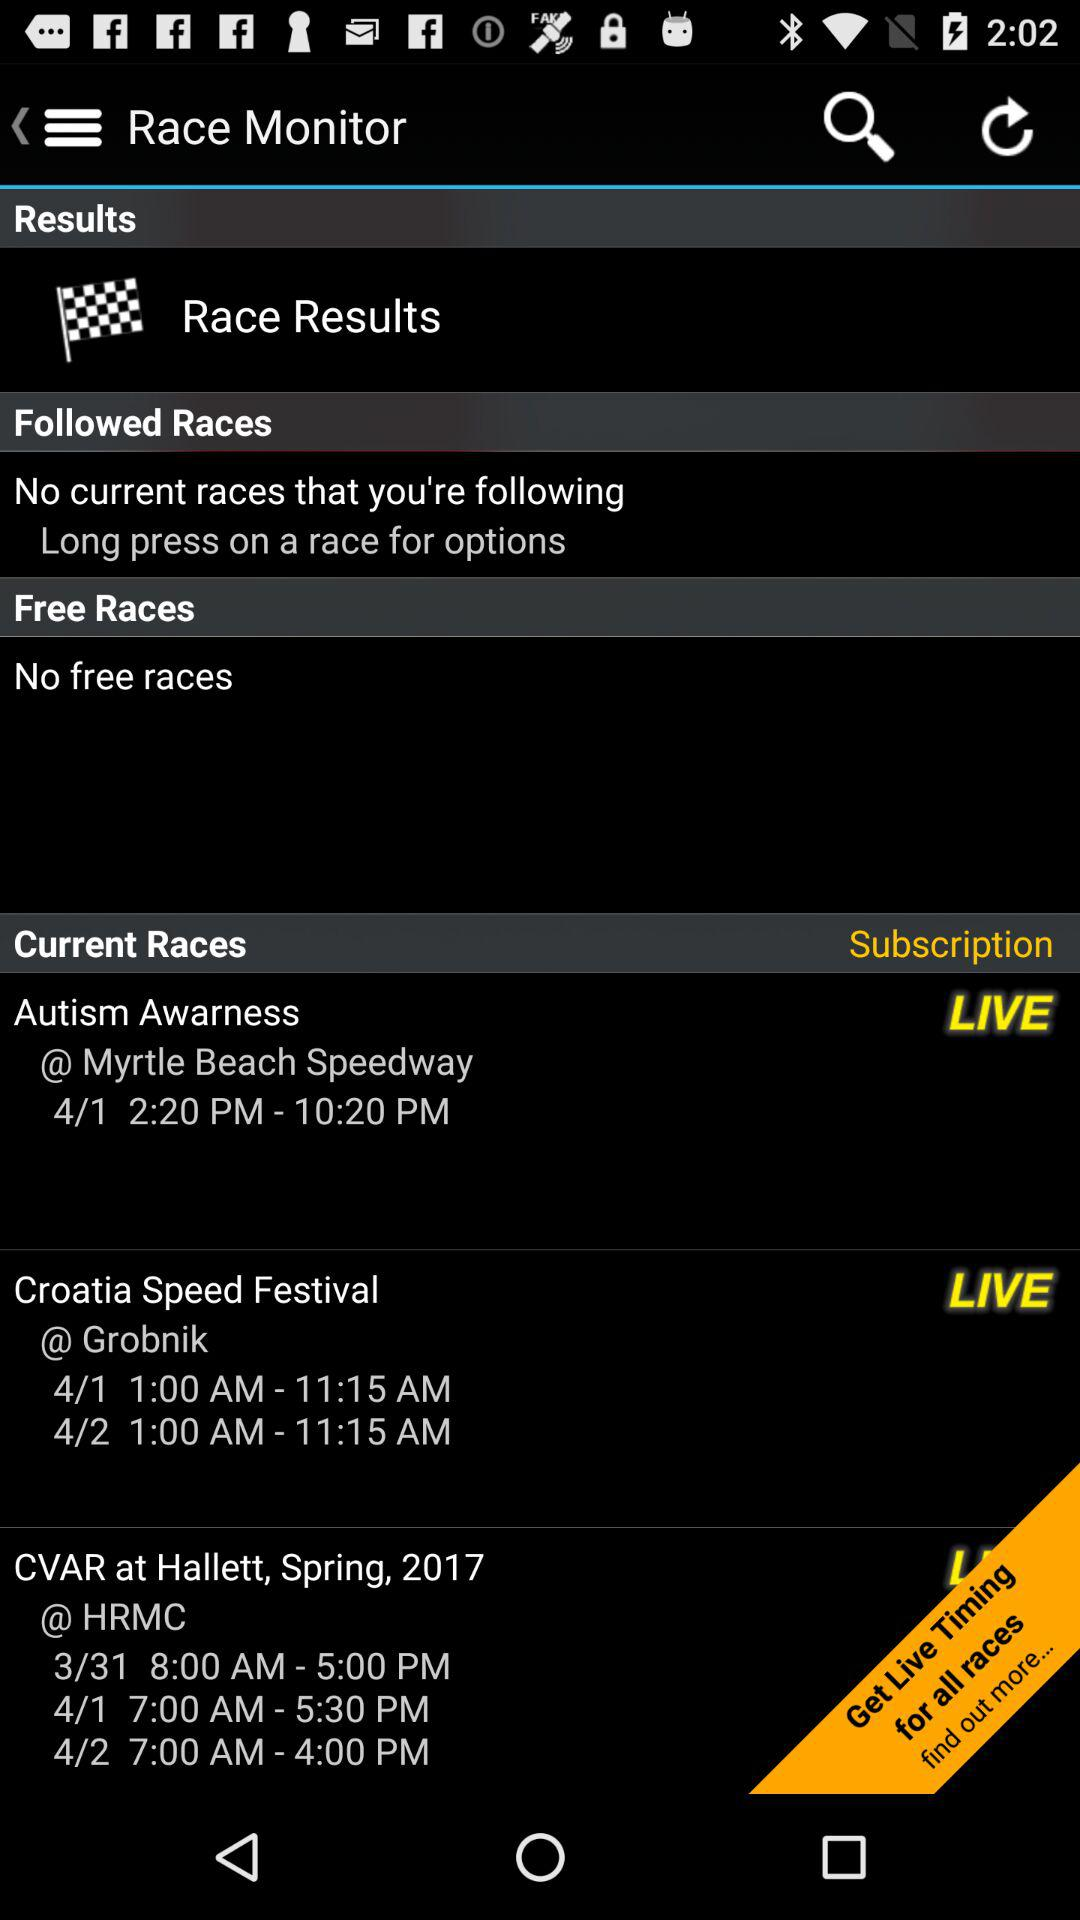How many free races are there? Based on the information visible in the image, there are currently no free races listed under the 'Free Races' section on the Race Monitor app. 